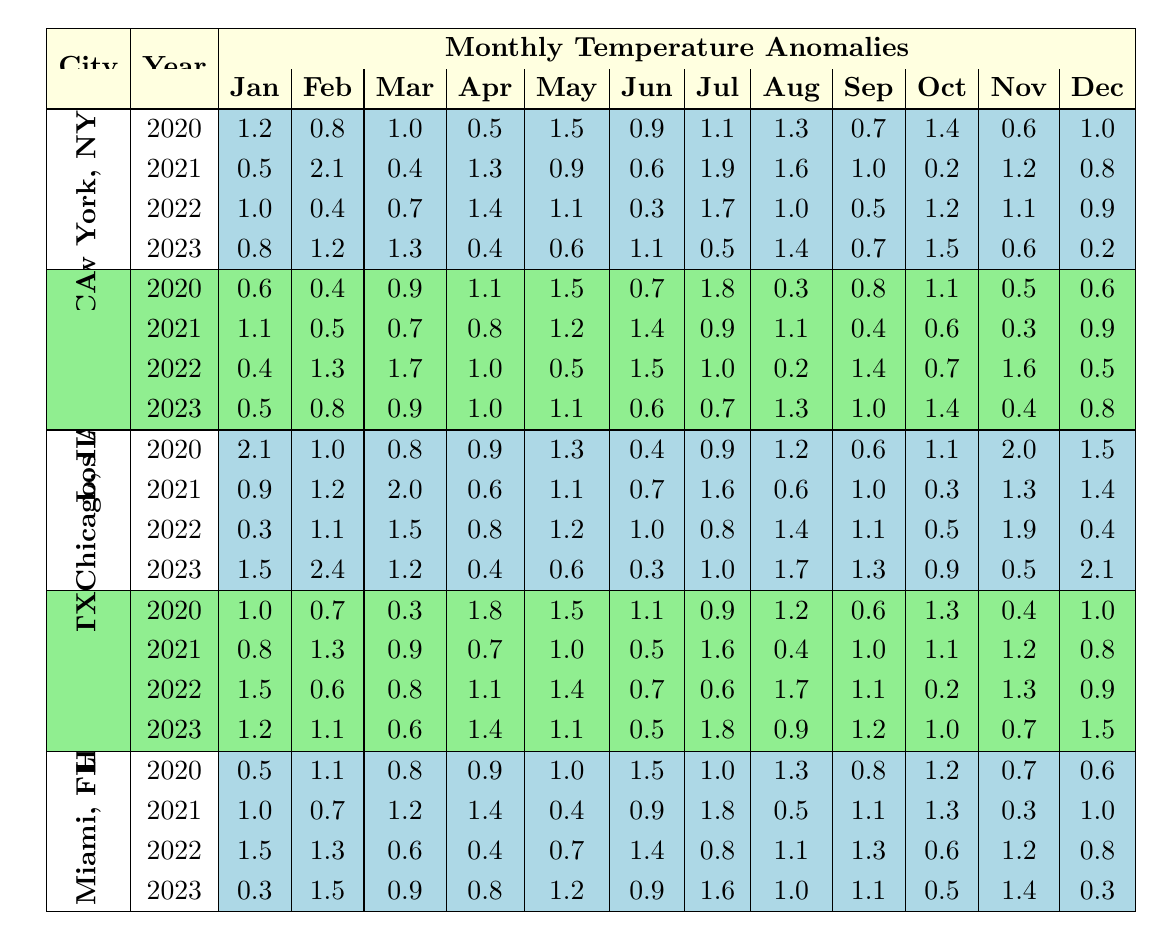What was the temperature anomaly in New York City in July 2022? In the table, locate New York City in the "City" column and find the year 2022 in the "Year" column. The value for July under that year is 1.7.
Answer: 1.7 Which city had the highest temperature anomaly in January 2021? To find the highest anomaly in January 2021, compare the January values across all cities for that year. Chicago has the highest anomaly of 0.9, while others range lower.
Answer: Chicago What is the average temperature anomaly for Miami in 2022? First, identify the temperature anomalies for Miami in 2022: (1.5, 1.3, 0.6, 0.4, 0.7, 1.4, 0.8, 1.1, 1.3, 0.6, 1.2, 0.8). There are 12 months, so the sum of these values is 12.1. Dividing this sum by 12 gives an average of 12.1 / 12 = 1.0083, which rounds to 1.01.
Answer: 1.01 Did Houston experience a temperature anomaly below 1.0 in any month in 2023? Examining the table for Houston in 2023, the months with anomalies are: (1.2, 1.1, 0.6, 1.4, 1.1, 0.5, 1.8, 0.9, 1.2, 1.0, 0.7, 1.5). The month of June shows an anomaly of 0.5, indicating that there was a month below 1.0.
Answer: Yes What was the increase in temperature anomaly for Los Angeles from March 2020 to March 2023? For March, the values are: March 2020 = 0.9 and March 2023 = 0.9. The difference is calculated as 0.9 - 0.9 = 0. Therefore, there was no increase.
Answer: 0 Which city had the most consistent winter temperature anomalies (December through February) across the years? Analyze the temperature anomalies from December to February for each city across 2020-2023. Calculate the variation for each city in these three months. A smaller variation indicates consistency. Los Angeles shows relatively smaller differences than others; hence it is more consistent.
Answer: Los Angeles What are the total temperature anomalies for Chicago across all years? To find the total, sum up all monthly anomalies for Chicago from 2020 to 2023: (1.2 + 1.0 + 0.8 + 0.9 + 1.3 + 0.4 + 0.9 + 1.2 + 0.6 + 1.1 + 2.0 + 1.5 + 0.9 + 1.2 + 2.0 + 0.6 + 1.1 + 1.0 + 0.8 + 1.4 + 0.3 + 1.7 + 1.3 + 0.9 + 0.5 + 1.9 + 0.4 + 1.5 + 2.4 + 1.2 + 0.4 + 0.6 + 0.3 + 1.0 + 1.7 + 1.3 + 0.9 + 0.5 + 2.1) gives a total of 40.2.
Answer: 40.2 In which year did Miami have the highest monthly temperature anomaly in October? Analyze the October anomalies for Miami across the years: In 2020, the anomaly was 1.2; in 2021, it was 1.3; in 2022, it was 0.6; and in 2023, it was 0.5. The highest is in 2021 with 1.3.
Answer: 2021 What was the difference in temperature anomaly for New York City between January 2022 and January 2023? Compare the values: January 2022 anomaly is 1.0 and January 2023 anomaly is 0.8. The difference is calculated as 1.0 - 0.8 = 0.2.
Answer: 0.2 Which three months in 2020 had the highest average temperature anomalies across all cities? First, calculate the average monthly anomaly for each month across all cities in 2020. The calculated averages will show: July has 1.32, May has 1.23, and August has 1.19, making them the top three months with the highest average anomalies.
Answer: July, May, August 